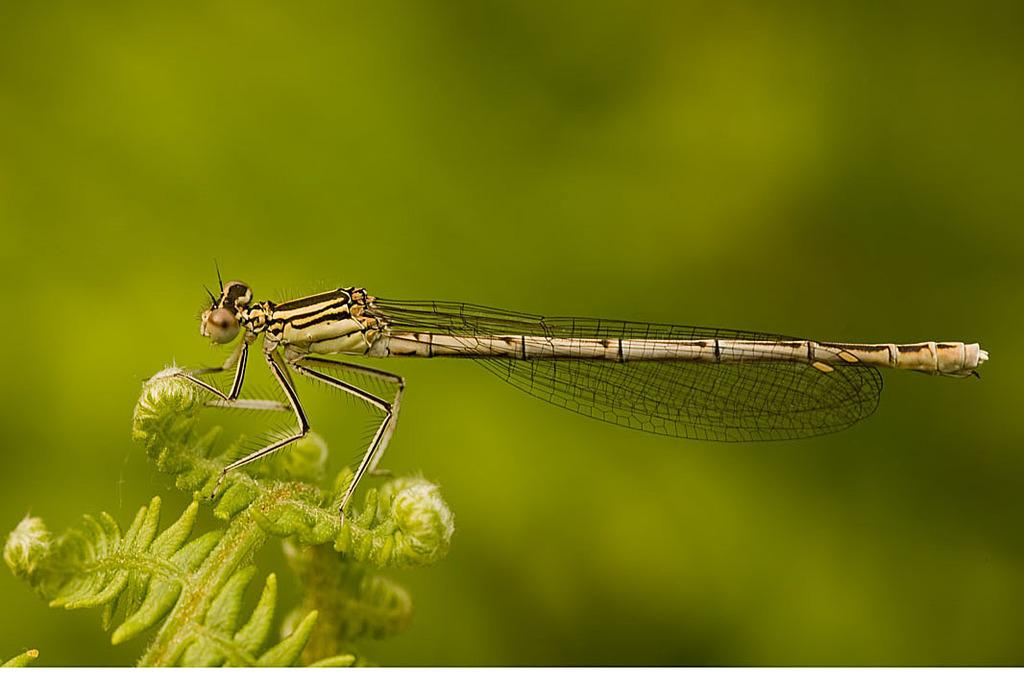What insect can be seen in the picture? There is a Dragonfly in the picture. Where is the Dragonfly located? The Dragonfly is on a plant. What colors are present on the Dragonfly? The Dragonfly is black and light brown in color. What advice does the Dragonfly give to the snake in the image? There is no snake present in the image, so the Dragonfly cannot give any advice to a snake. 